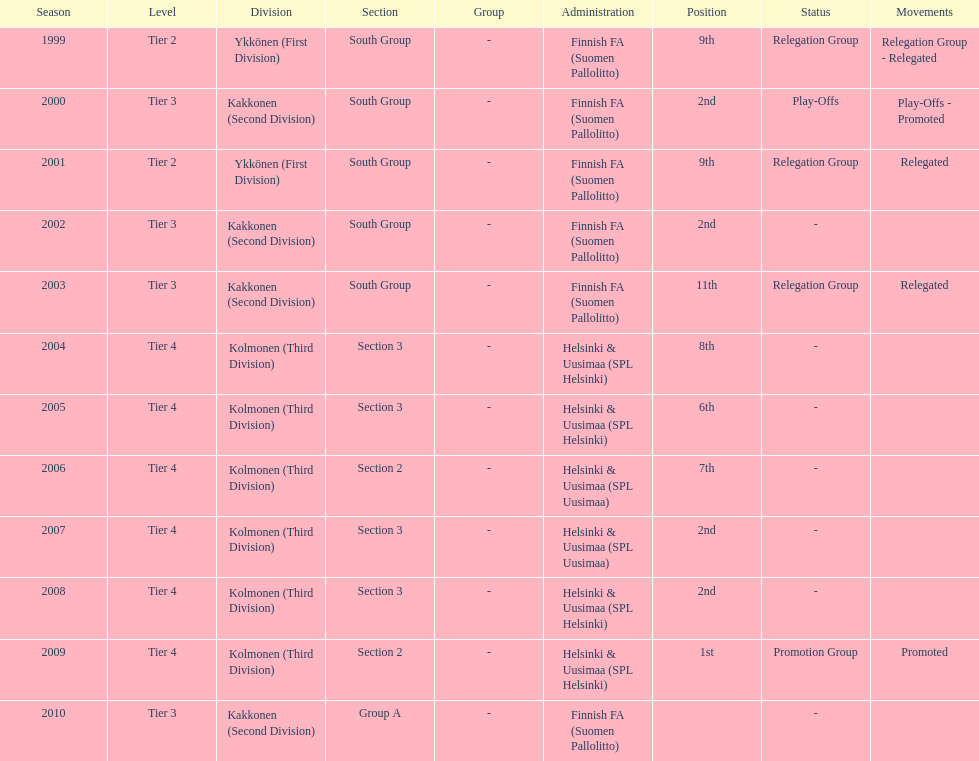How many 2nd positions were there? 4. 